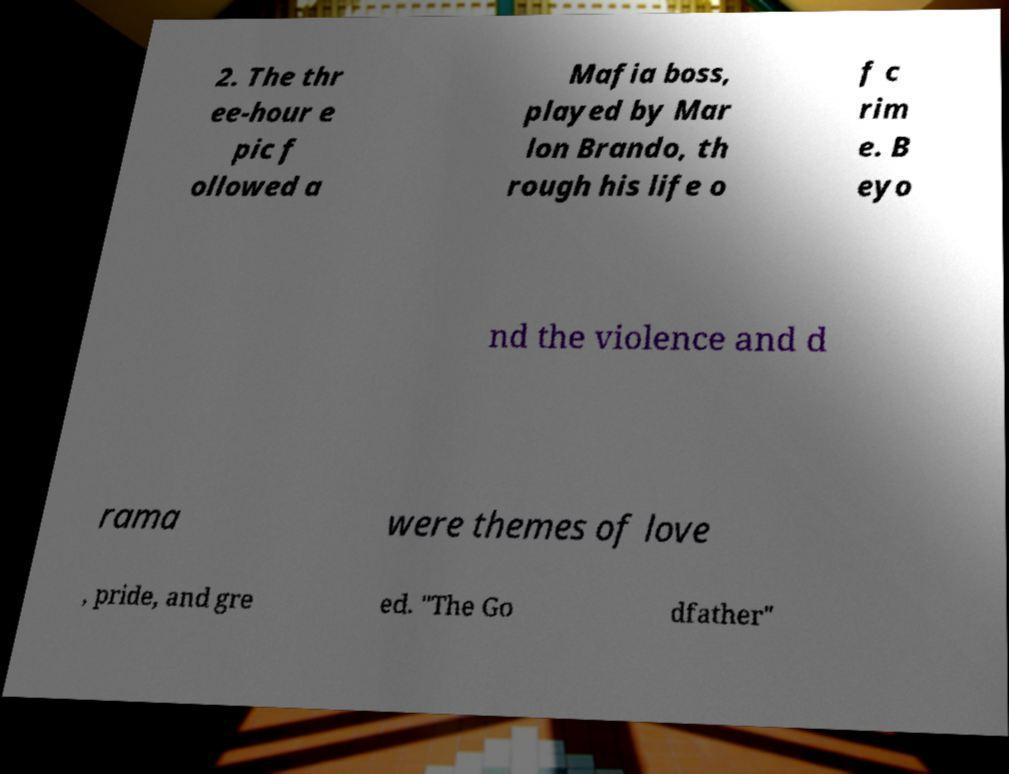Could you assist in decoding the text presented in this image and type it out clearly? 2. The thr ee-hour e pic f ollowed a Mafia boss, played by Mar lon Brando, th rough his life o f c rim e. B eyo nd the violence and d rama were themes of love , pride, and gre ed. "The Go dfather" 